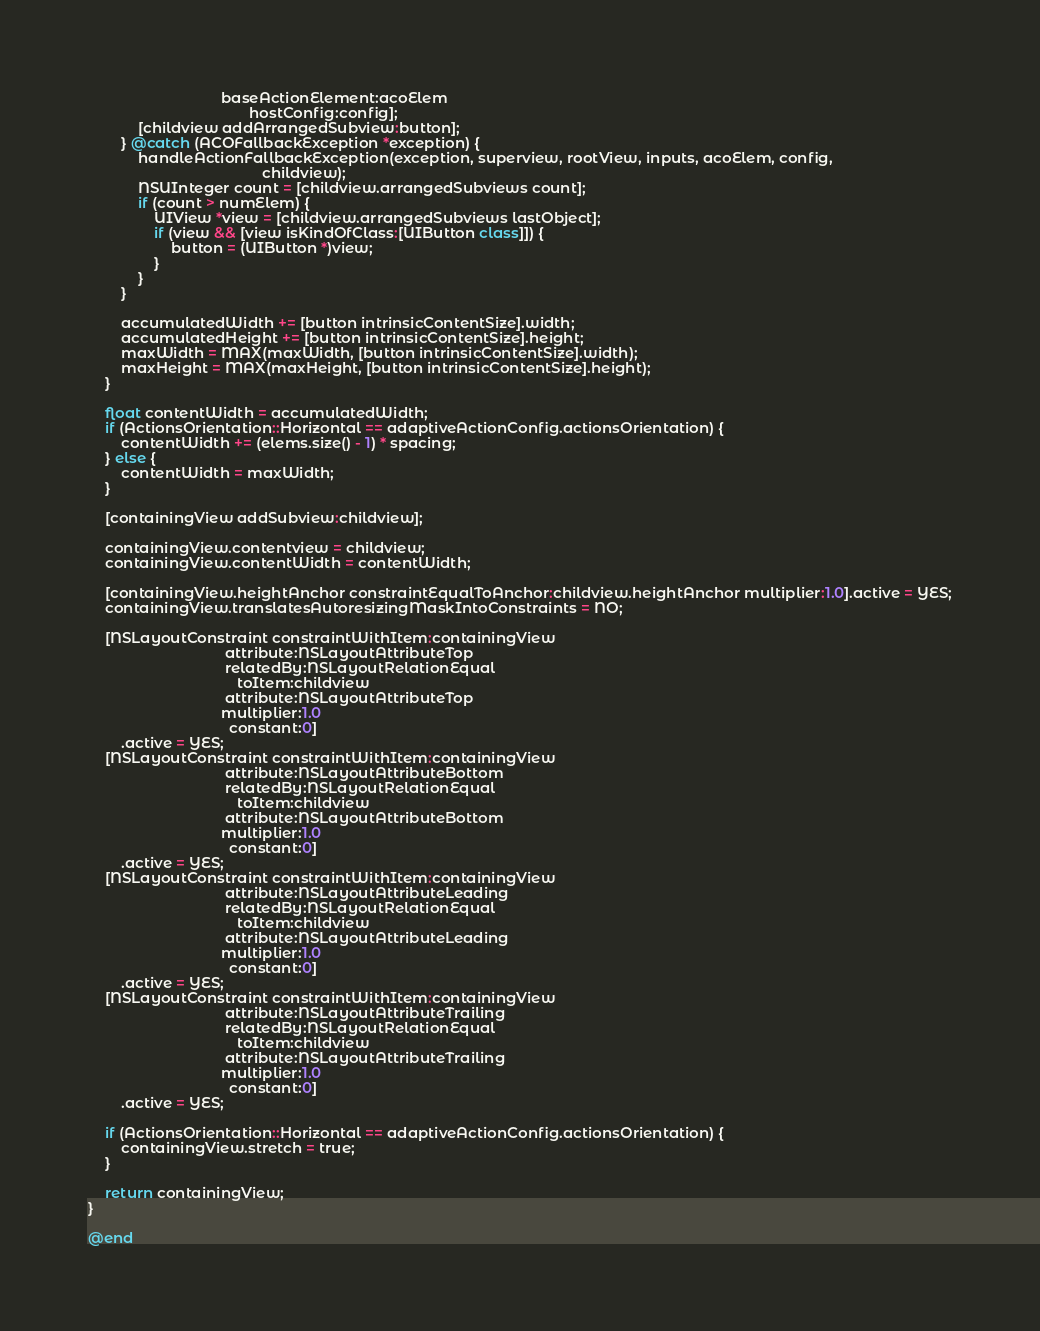<code> <loc_0><loc_0><loc_500><loc_500><_ObjectiveC_>                                baseActionElement:acoElem
                                       hostConfig:config];
            [childview addArrangedSubview:button];
        } @catch (ACOFallbackException *exception) {
            handleActionFallbackException(exception, superview, rootView, inputs, acoElem, config,
                                          childview);
            NSUInteger count = [childview.arrangedSubviews count];
            if (count > numElem) {
                UIView *view = [childview.arrangedSubviews lastObject];
                if (view && [view isKindOfClass:[UIButton class]]) {
                    button = (UIButton *)view;
                }
            }
        }

        accumulatedWidth += [button intrinsicContentSize].width;
        accumulatedHeight += [button intrinsicContentSize].height;
        maxWidth = MAX(maxWidth, [button intrinsicContentSize].width);
        maxHeight = MAX(maxHeight, [button intrinsicContentSize].height);
    }

    float contentWidth = accumulatedWidth;
    if (ActionsOrientation::Horizontal == adaptiveActionConfig.actionsOrientation) {
        contentWidth += (elems.size() - 1) * spacing;
    } else {
        contentWidth = maxWidth;
    }

    [containingView addSubview:childview];

    containingView.contentview = childview;
    containingView.contentWidth = contentWidth;

    [containingView.heightAnchor constraintEqualToAnchor:childview.heightAnchor multiplier:1.0].active = YES;
    containingView.translatesAutoresizingMaskIntoConstraints = NO;

    [NSLayoutConstraint constraintWithItem:containingView
                                 attribute:NSLayoutAttributeTop
                                 relatedBy:NSLayoutRelationEqual
                                    toItem:childview
                                 attribute:NSLayoutAttributeTop
                                multiplier:1.0
                                  constant:0]
        .active = YES;
    [NSLayoutConstraint constraintWithItem:containingView
                                 attribute:NSLayoutAttributeBottom
                                 relatedBy:NSLayoutRelationEqual
                                    toItem:childview
                                 attribute:NSLayoutAttributeBottom
                                multiplier:1.0
                                  constant:0]
        .active = YES;
    [NSLayoutConstraint constraintWithItem:containingView
                                 attribute:NSLayoutAttributeLeading
                                 relatedBy:NSLayoutRelationEqual
                                    toItem:childview
                                 attribute:NSLayoutAttributeLeading
                                multiplier:1.0
                                  constant:0]
        .active = YES;
    [NSLayoutConstraint constraintWithItem:containingView
                                 attribute:NSLayoutAttributeTrailing
                                 relatedBy:NSLayoutRelationEqual
                                    toItem:childview
                                 attribute:NSLayoutAttributeTrailing
                                multiplier:1.0
                                  constant:0]
        .active = YES;

    if (ActionsOrientation::Horizontal == adaptiveActionConfig.actionsOrientation) {
        containingView.stretch = true;
    }

    return containingView;
}

@end
</code> 